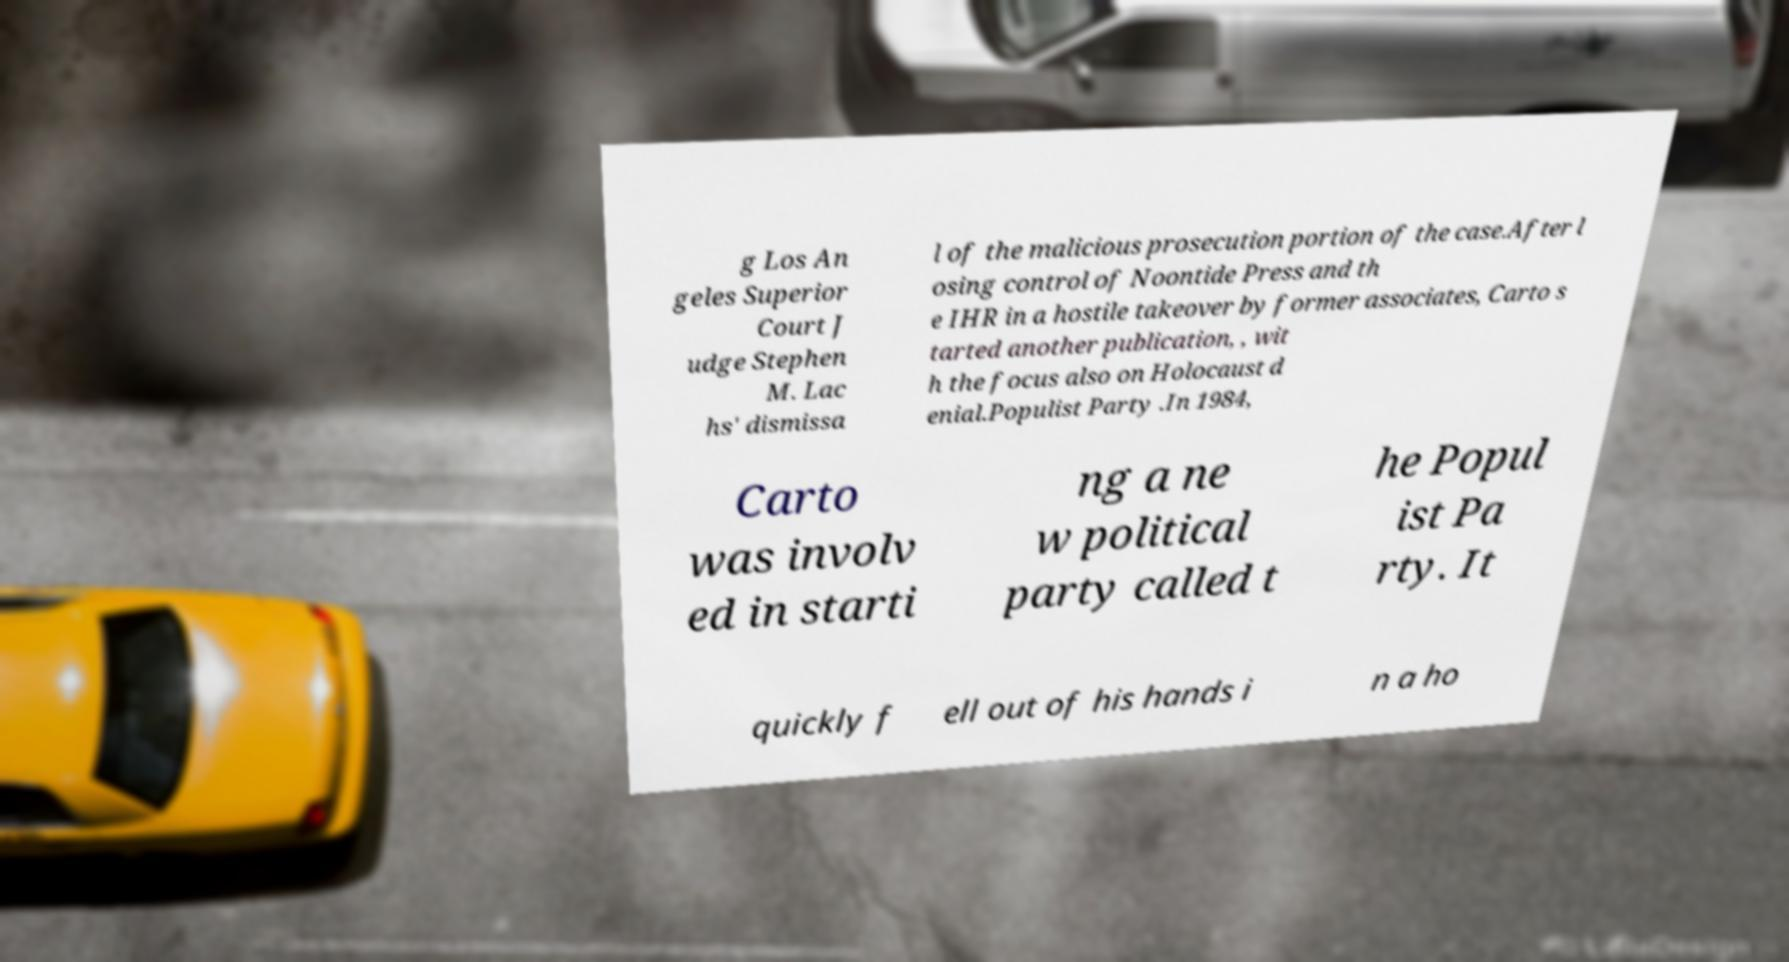Please read and relay the text visible in this image. What does it say? g Los An geles Superior Court J udge Stephen M. Lac hs' dismissa l of the malicious prosecution portion of the case.After l osing control of Noontide Press and th e IHR in a hostile takeover by former associates, Carto s tarted another publication, , wit h the focus also on Holocaust d enial.Populist Party .In 1984, Carto was involv ed in starti ng a ne w political party called t he Popul ist Pa rty. It quickly f ell out of his hands i n a ho 